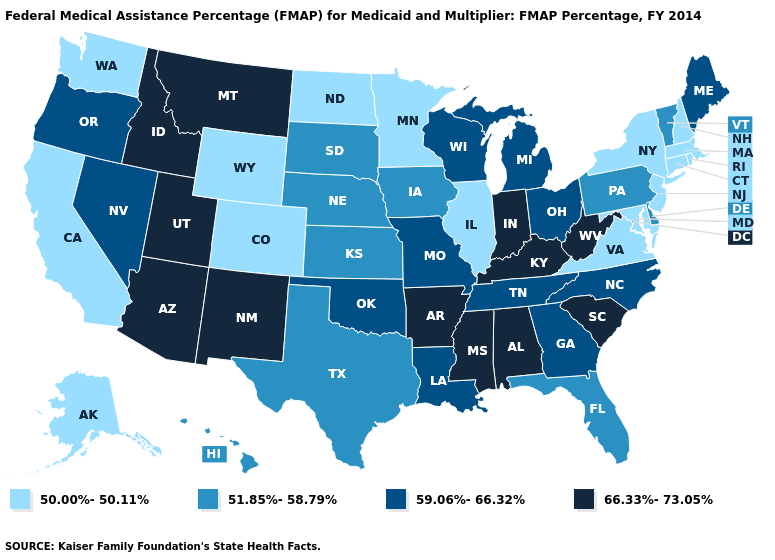Name the states that have a value in the range 59.06%-66.32%?
Keep it brief. Georgia, Louisiana, Maine, Michigan, Missouri, Nevada, North Carolina, Ohio, Oklahoma, Oregon, Tennessee, Wisconsin. What is the highest value in states that border Wyoming?
Short answer required. 66.33%-73.05%. What is the value of Virginia?
Keep it brief. 50.00%-50.11%. What is the highest value in the West ?
Short answer required. 66.33%-73.05%. Which states have the lowest value in the USA?
Give a very brief answer. Alaska, California, Colorado, Connecticut, Illinois, Maryland, Massachusetts, Minnesota, New Hampshire, New Jersey, New York, North Dakota, Rhode Island, Virginia, Washington, Wyoming. What is the highest value in states that border Michigan?
Answer briefly. 66.33%-73.05%. Which states have the highest value in the USA?
Answer briefly. Alabama, Arizona, Arkansas, Idaho, Indiana, Kentucky, Mississippi, Montana, New Mexico, South Carolina, Utah, West Virginia. What is the value of Vermont?
Quick response, please. 51.85%-58.79%. Name the states that have a value in the range 66.33%-73.05%?
Write a very short answer. Alabama, Arizona, Arkansas, Idaho, Indiana, Kentucky, Mississippi, Montana, New Mexico, South Carolina, Utah, West Virginia. Name the states that have a value in the range 51.85%-58.79%?
Answer briefly. Delaware, Florida, Hawaii, Iowa, Kansas, Nebraska, Pennsylvania, South Dakota, Texas, Vermont. Among the states that border California , which have the highest value?
Give a very brief answer. Arizona. Does the first symbol in the legend represent the smallest category?
Quick response, please. Yes. What is the value of Oklahoma?
Keep it brief. 59.06%-66.32%. What is the value of New Hampshire?
Write a very short answer. 50.00%-50.11%. 